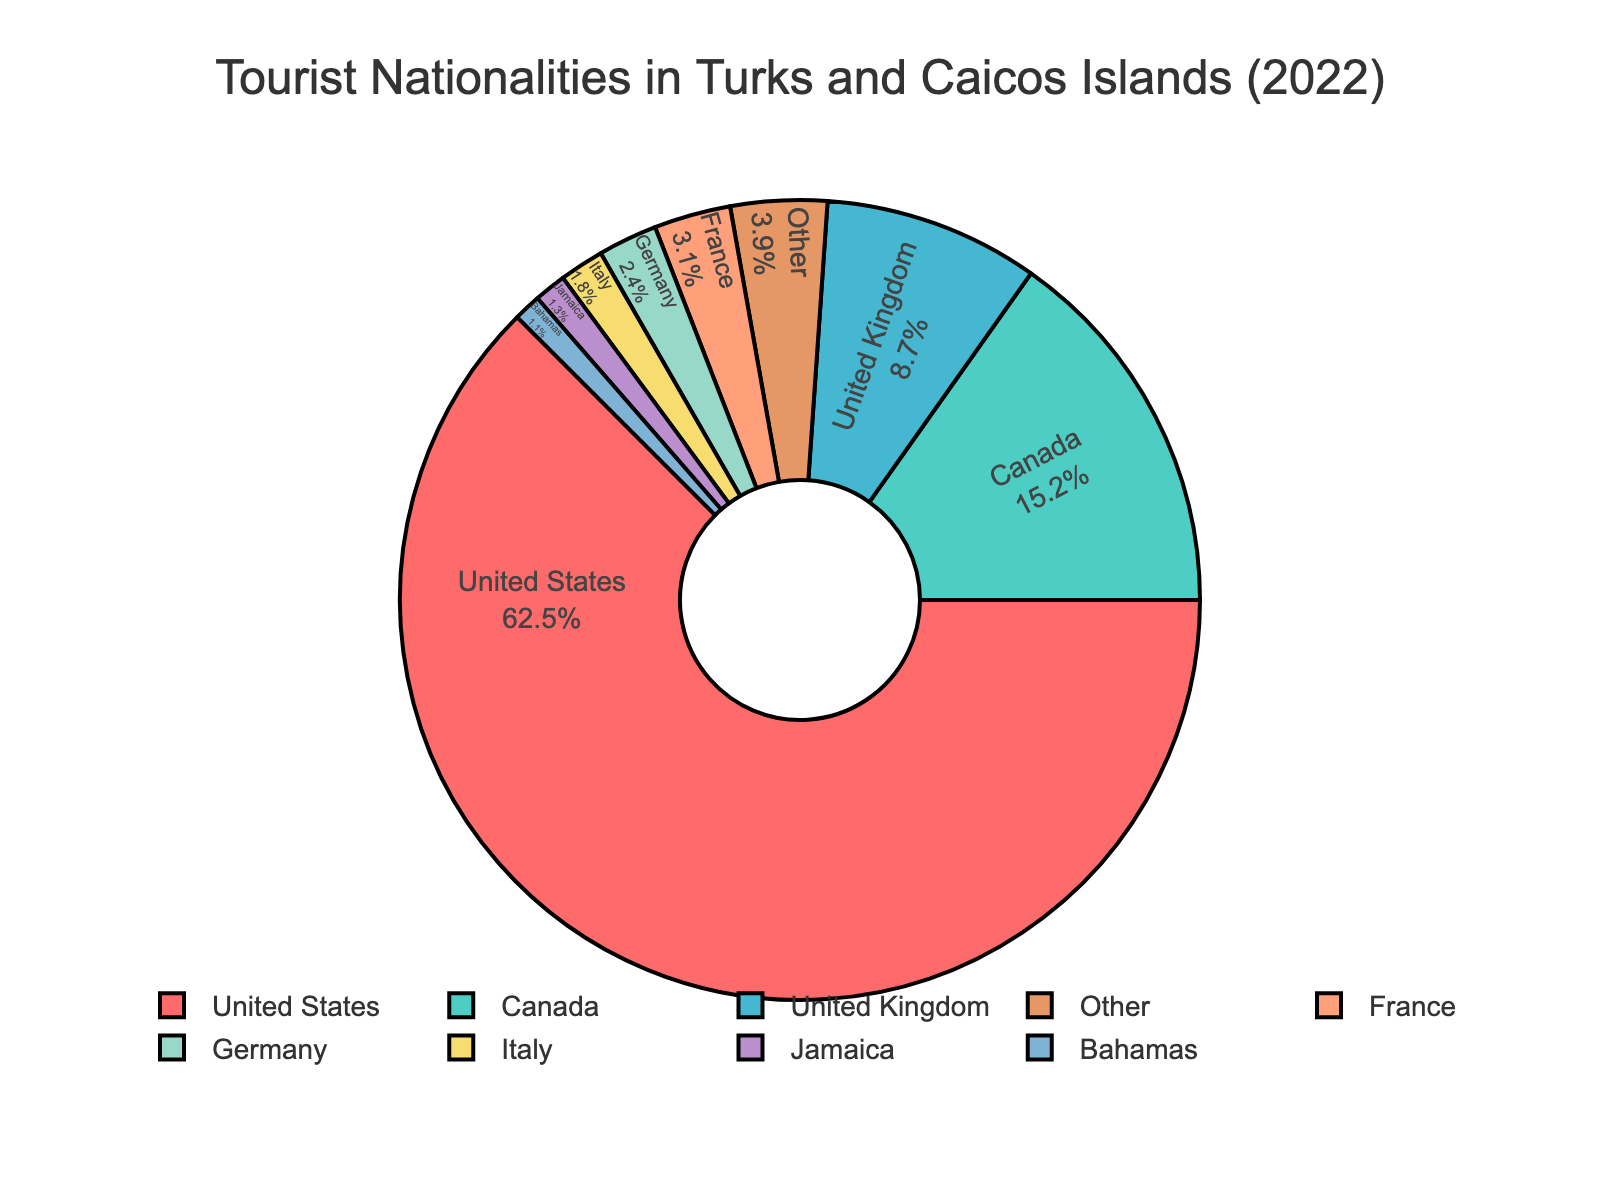How many countries have a percentage below 1%? The 'Other' category combined all countries with percentages below 1%. All these countries amount to 6.0% in total. By identifying all percentages below 1% and summing them, the value matches those grouped as 'Other'.
Answer: 6 Which country has the largest share of tourists? The United States has the largest portion of the pie chart, with a percentage of 62.5%.
Answer: United States What is the combined percentage of tourists from Canada and the United Kingdom? Canada has 15.2% and the United Kingdom has 8.7%. Adding these: 15.2% + 8.7% = 23.9%.
Answer: 23.9% Which country has a larger percentage of tourists, France or Germany? France has a percentage of 3.1% while Germany has 2.4%. Hence, France has a larger percentage.
Answer: France What is the percentage for the 'Other' category? To find the percentage of the 'Other' category, sum all individual country percentages below 1%: 0.9% (Brazil) + 0.8% (Australia) + 0.7% (Spain) + 0.6% (Netherlands) + 0.5% (Switzerland) + 0.4% (Sweden) = 3.9%.
Answer: 3.9% Is the percentage of tourists from the Bahamas greater than or lesser than that from Jamaica? The Bahamas have a percentage of 1.1% while Jamaica has 1.3%, meaning tourists from the Bahamas are lesser than from Jamaica.
Answer: Lesser than What is the combined percentage for France, Germany, and Italy? France has 3.1%, Germany has 2.4%, and Italy has 1.8%. Summing them: 3.1% + 2.4% + 1.8% = 7.3%.
Answer: 7.3% Are there more tourists from Canada or all 'Other' countries combined? Canada alone has a percentage of 15.2%, whereas the 'Other' category sums to 6.0%. Thus, there are more tourists from Canada.
Answer: Canada Which color represents the United States in the pie chart? The United States’ segment in the pie chart is depicted with the color red. This is visually identifiable.
Answer: red 